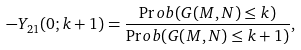<formula> <loc_0><loc_0><loc_500><loc_500>- Y _ { 2 1 } ( 0 ; k + 1 ) = \frac { \Pr o b ( G ( M , N ) \leq k ) } { \Pr o b ( G ( M , N ) \leq k + 1 ) } ,</formula> 